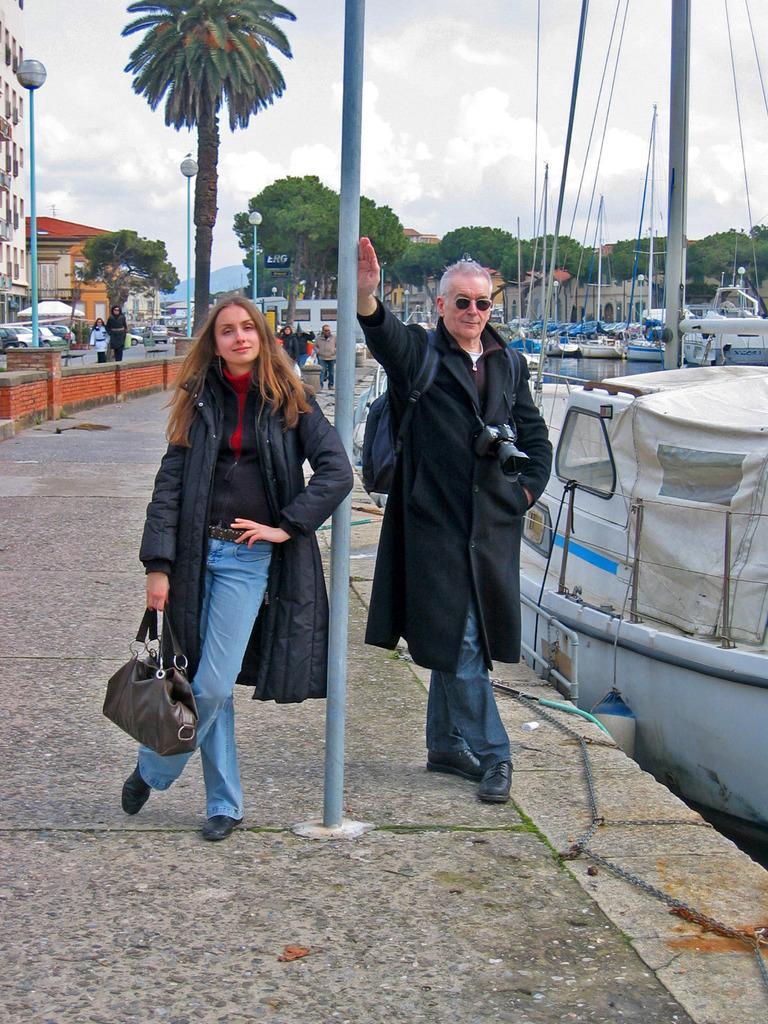Can you describe this image briefly? This image is clicked outside the city. There are two persons in this image. A man and a woman. The woman is wearing black jacket and holding a handbag. The man is wearing a black colored coat and wearing a bag pack. To the right there are many boats in the water. In the background there are many trees. And to the left there is a building with red roof. 